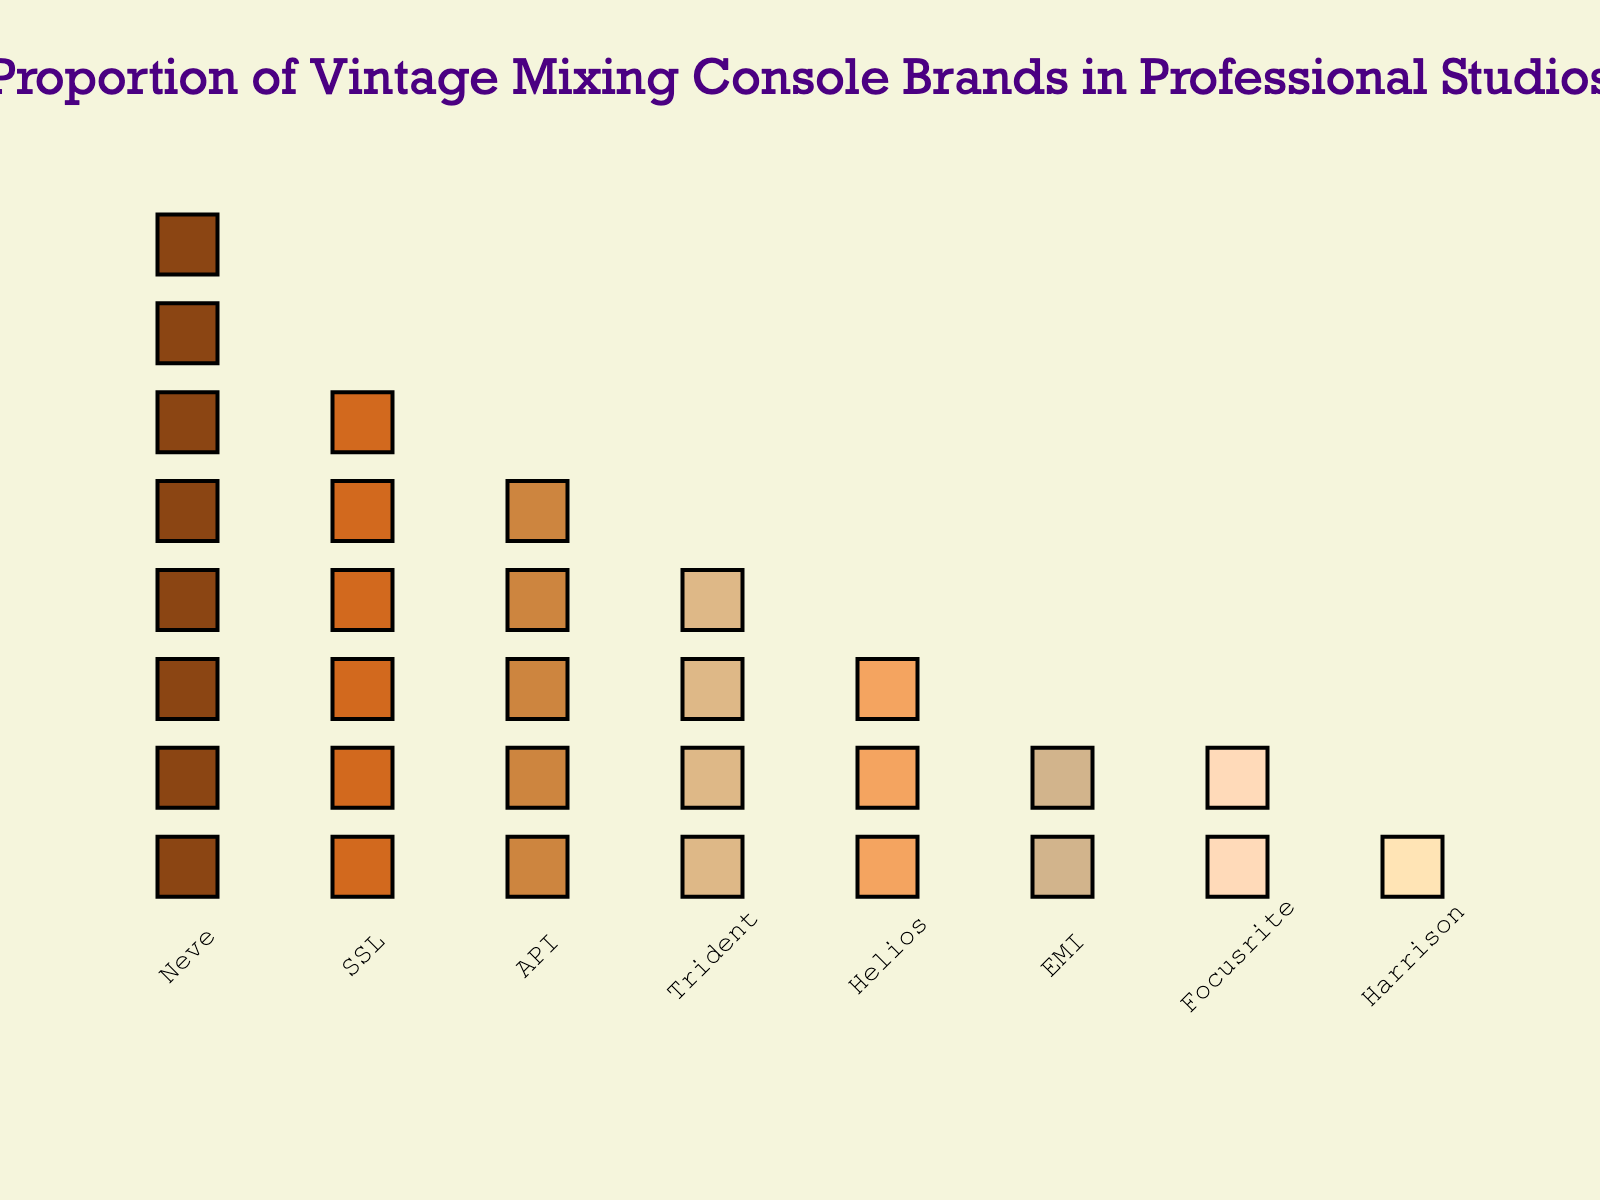What is the most common vintage mixing console brand in the professional studios according to the plot? By observing the plot, it's clear that 'Neve' has the highest number of console icons.
Answer: Neve How many brands have more than 4 mixing consoles in professional studios? The plot shows eight brands; counting those with more than 4 consoles, we get Neve, SSL, and API.
Answer: 3 Which brand has the least number of mixing consoles? By looking at the plot, Harrison is represented with only one console icon which is the least compared to others.
Answer: Harrison What is the total number of mixing consoles shown in the plot? Adding up all the numbers: 8 (Neve) + 6 (SSL) + 5 (API) + 4 (Trident) + 3 (Helios) + 2 (EMI) + 2 (Focusrite) + 1 (Harrison) equals 31.
Answer: 31 How many mixing consoles do SSL and API together have? From the plot, SSL has 6 and API has 5; adding these gives 6 + 5 = 11.
Answer: 11 Which brand has twice as many mixing consoles as EMI? EMI has 2 consoles. According to the plot, Helios has 3, which is more but not double. Trident has 4, which is exactly double.
Answer: Trident What's the difference in the number of mixing consoles between Neve and Trident? Neve has 8 and Trident has 4, so the difference is 8 - 4 = 4.
Answer: 4 Are there more API or EMI mixing consoles? From the plot, API has 5 and EMI has 2; thus, API has more.
Answer: API What proportion of the total consoles does Focusrite represent? Focusrite has 2 consoles out of a total of 31. The proportion is 2/31 ≈ 0.0645, which is approximately 6.45%.
Answer: 6.45% What is the combined total of consoles for Helios and Harrison? Helios has 3 and Harrison has 1, combining them gives 3 + 1 = 4.
Answer: 4 